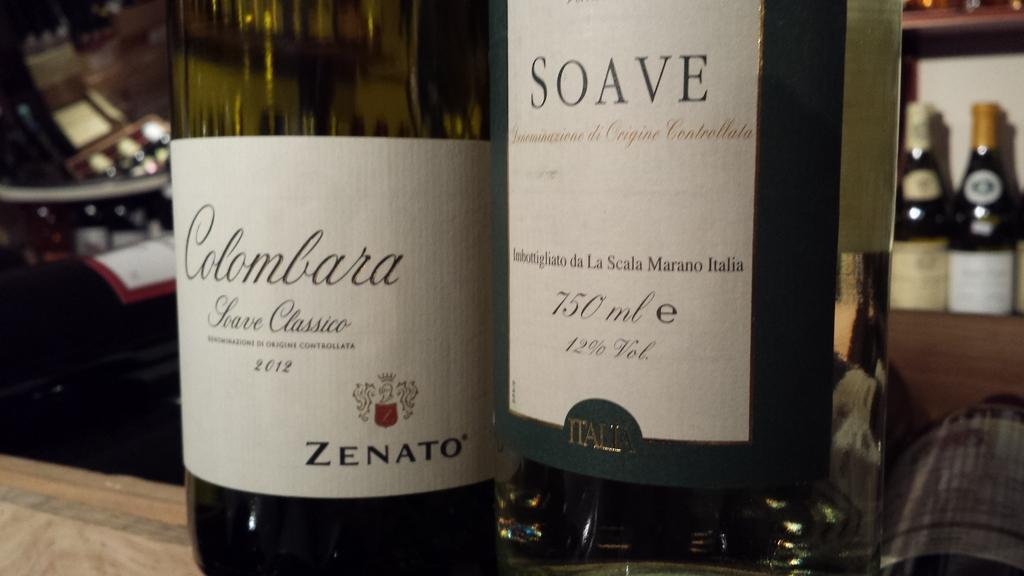<image>
Offer a succinct explanation of the picture presented. A bottle of Colombara is to the left of a bottle of Soave. 